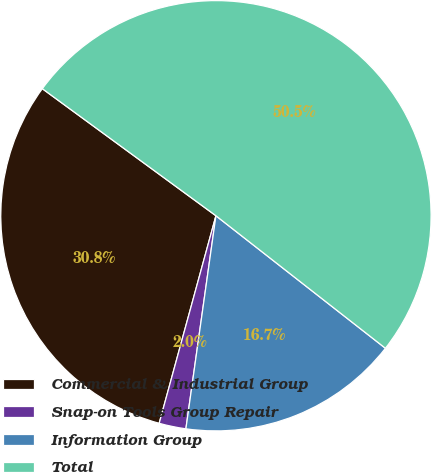<chart> <loc_0><loc_0><loc_500><loc_500><pie_chart><fcel>Commercial & Industrial Group<fcel>Snap-on Tools Group Repair<fcel>Information Group<fcel>Total<nl><fcel>30.81%<fcel>2.02%<fcel>16.67%<fcel>50.51%<nl></chart> 